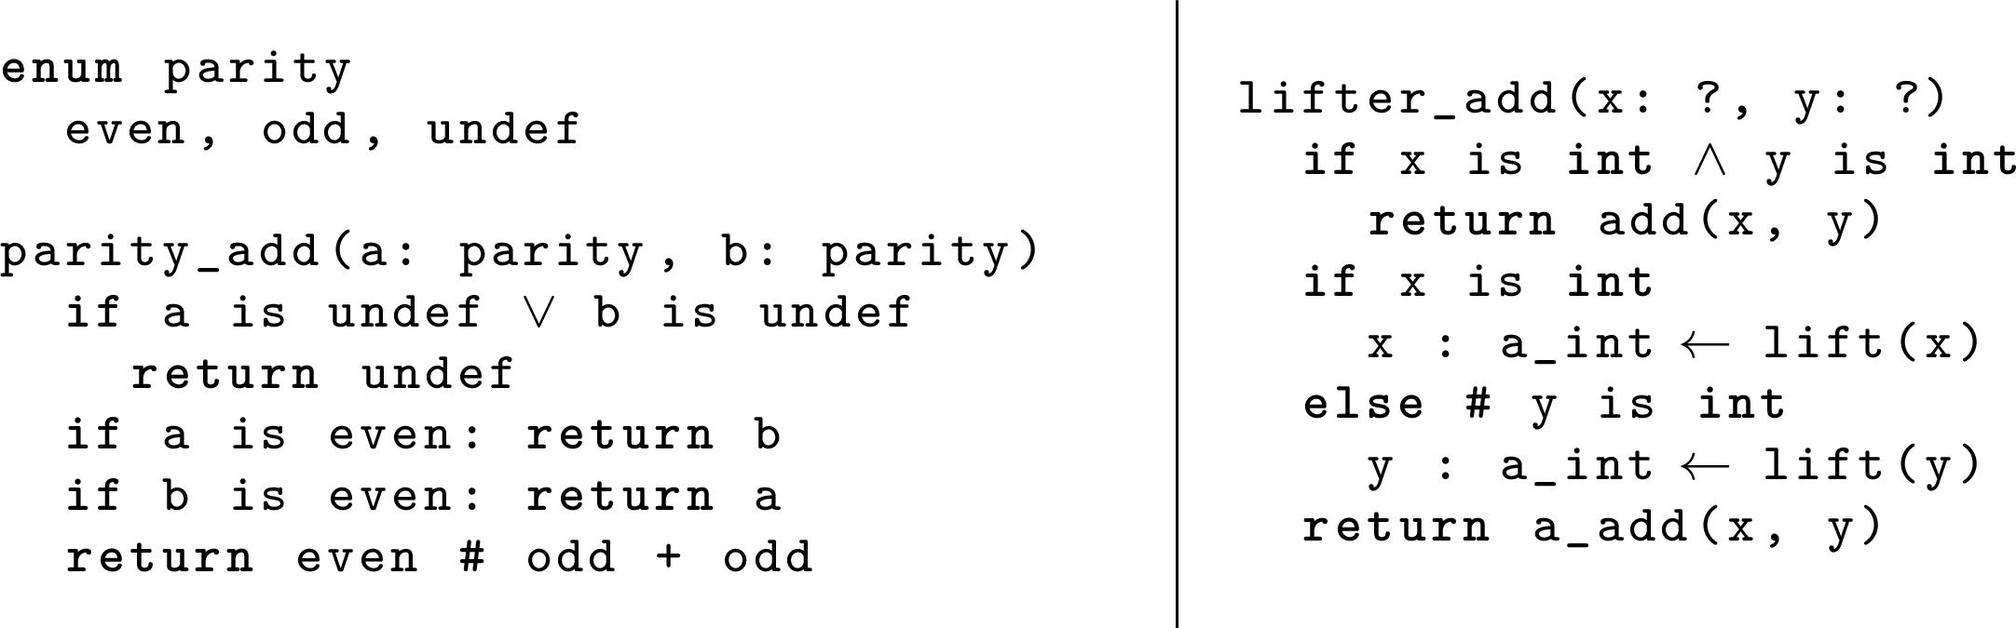How does the function `parity_add` handle cases where both inputs are odd? When both input values `a` and `b` are `odd` in the `parity_add` function, as per the logic shown in the image, the result is `even`. This follows from the general rule that the sum of two odd numbers is always even. 